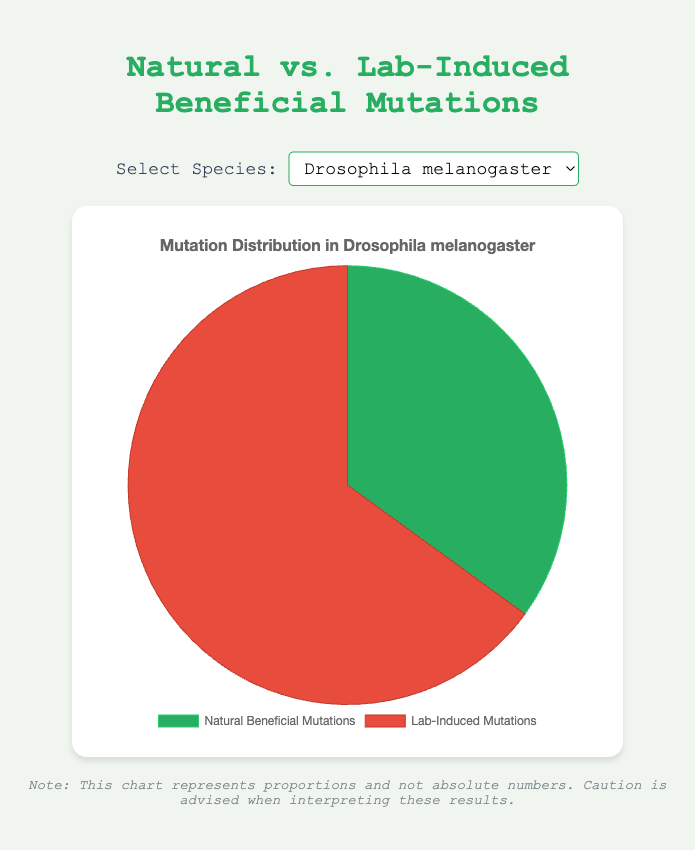Which species has the highest proportion of natural beneficial mutations? To find the species with the highest proportion of natural beneficial mutations, check the values for each species: Drosophila melanogaster (35), Escherichia coli (50), Arabidopsis thaliana (40). The highest value is 50 for Escherichia coli.
Answer: Escherichia coli What is the percentage of lab-induced mutations in Drosophila melanogaster? To determine the percentage, sum the values for Drosophila melanogaster: 35 (natural) + 65 (lab-induced) = 100. The percentage is (65/100) * 100 = 65%.
Answer: 65% Compare the proportion of natural beneficial mutations between Arabidopsis thaliana and Drosophila melanogaster. Which one is higher? Compare the values: Arabidopsis thaliana (40) and Drosophila melanogaster (35). Arabidopsis thaliana has a higher proportion of natural beneficial mutations.
Answer: Arabidopsis thaliana What is the difference in the number of lab-induced mutations and natural beneficial mutations in Escherichia coli? Calculate the difference: Escherichia coli lab-induced (50) - natural (50) = 0.
Answer: 0 How much larger is the proportion of lab-induced mutations compared to natural beneficial mutations in Arabidopsis thaliana? Check Arabidopsis thaliana values: lab-induced (60) and natural (40). The difference is 60 - 40 = 20.
Answer: 20 Which species shows an equal proportion of natural beneficial mutations and lab-induced mutations? Identify species with equal values for both types: Escherichia coli has 50 for both natural and lab-induced mutations.
Answer: Escherichia coli What proportion of mutations are naturally occurring in Drosophila melanogaster? Calculate the proportion: Drosophila melanogaster natural (35) / (35 + 65) = 35/100 = 35%.
Answer: 35% In the pie chart for Arabidopsis thaliana, what color represents lab-induced mutations? In the chart, lab-induced mutations are represented by red.
Answer: Red What is the combined total of natural beneficial mutations for all species? Sum the values: Drosophila melanogaster (35) + Escherichia coli (50) + Arabidopsis thaliana (40) = 35 + 50 + 40 = 125.
Answer: 125 If you combine all data points, what percentage of total mutations are lab-induced across all species? First, sum all data points: (35 + 50 + 40) + (65 + 50 + 60) = 290. Then, sum lab-induced: 65 + 50 + 60 = 175. Percentage is (175/290) * 100 ≈ 60.34%.
Answer: 60.34% 